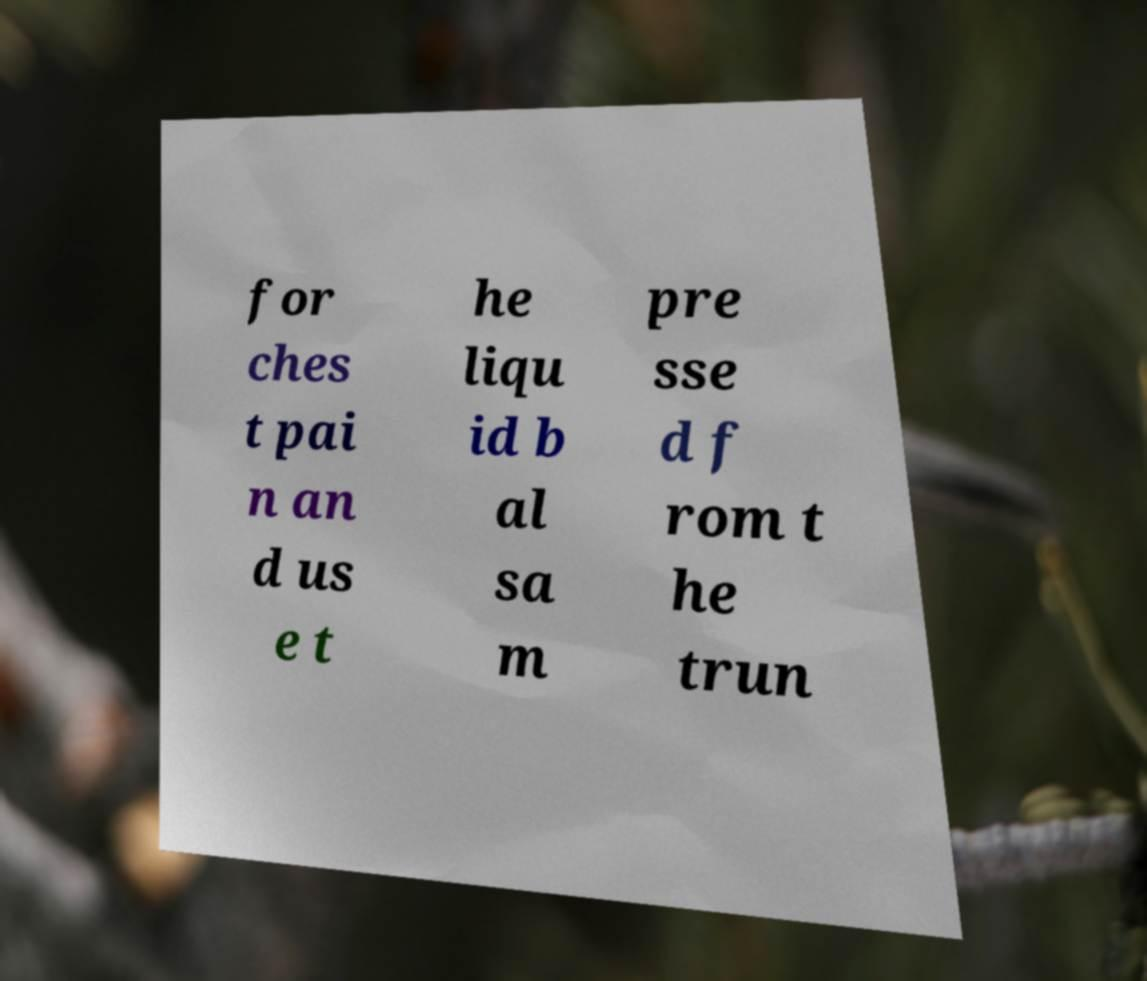Please identify and transcribe the text found in this image. for ches t pai n an d us e t he liqu id b al sa m pre sse d f rom t he trun 